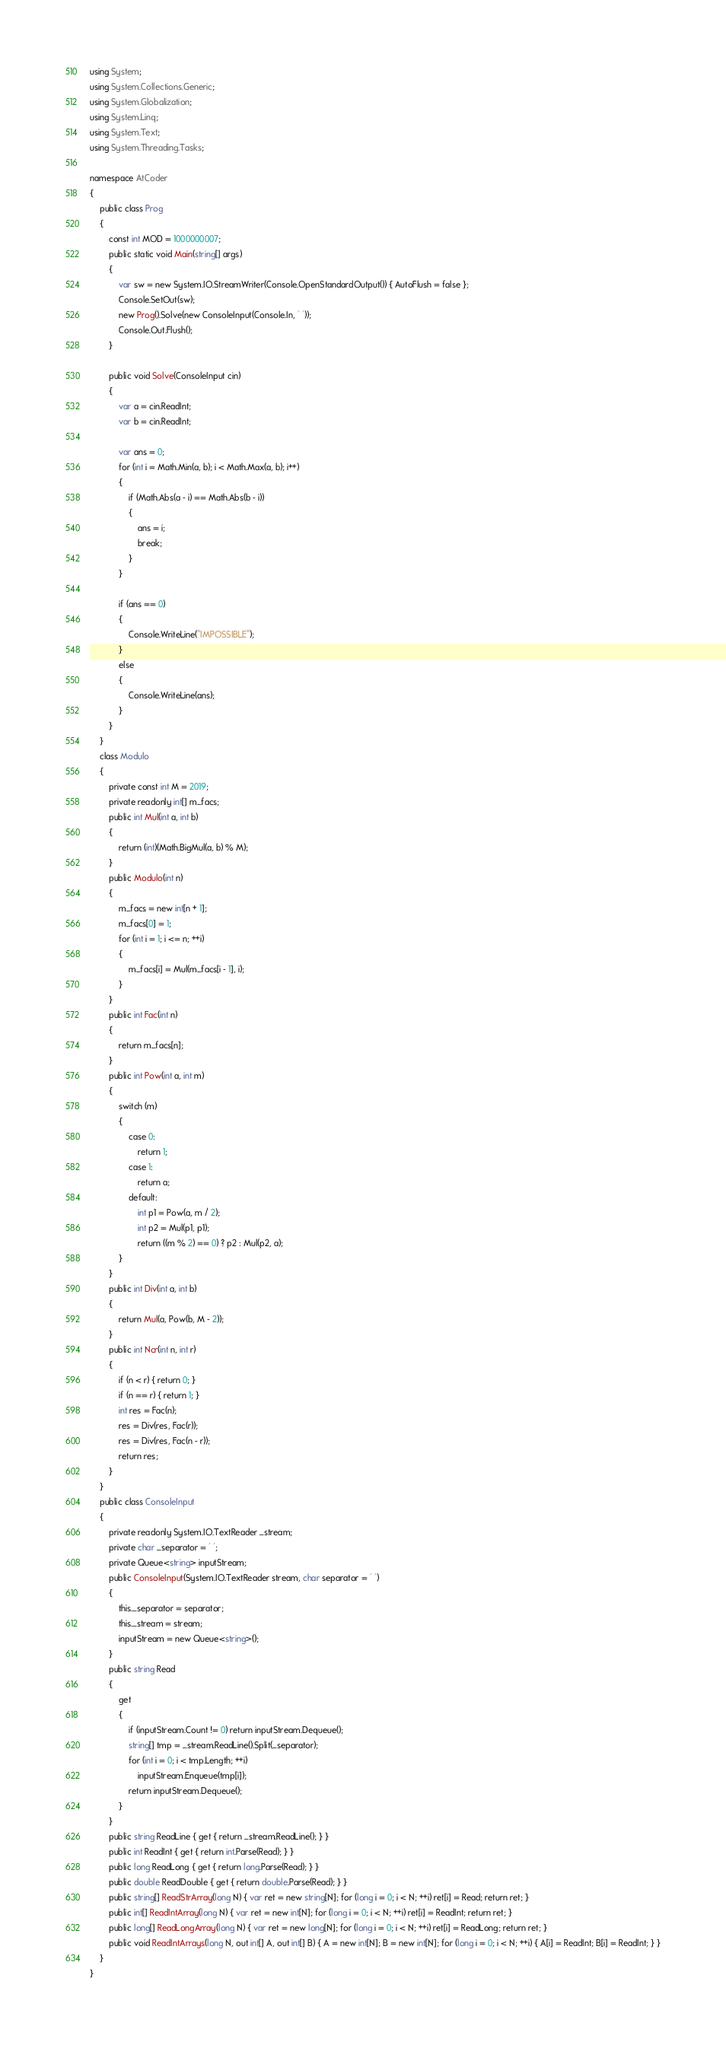<code> <loc_0><loc_0><loc_500><loc_500><_C#_>using System;
using System.Collections.Generic;
using System.Globalization;
using System.Linq;
using System.Text;
using System.Threading.Tasks;

namespace AtCoder
{
    public class Prog
    {
        const int MOD = 1000000007;
        public static void Main(string[] args)
        {
            var sw = new System.IO.StreamWriter(Console.OpenStandardOutput()) { AutoFlush = false };
            Console.SetOut(sw);
            new Prog().Solve(new ConsoleInput(Console.In, ' '));
            Console.Out.Flush();
        }

        public void Solve(ConsoleInput cin)
        {
            var a = cin.ReadInt;
            var b = cin.ReadInt;

            var ans = 0;
            for (int i = Math.Min(a, b); i < Math.Max(a, b); i++)
            {
                if (Math.Abs(a - i) == Math.Abs(b - i))
                {
                    ans = i;
                    break;
                }
            }

            if (ans == 0)
            {
                Console.WriteLine("IMPOSSIBLE");
            }
            else
            {
                Console.WriteLine(ans);
            }
        }
    }
    class Modulo
    {
        private const int M = 2019;
        private readonly int[] m_facs;
        public int Mul(int a, int b)
        {
            return (int)(Math.BigMul(a, b) % M);
        }
        public Modulo(int n)
        {
            m_facs = new int[n + 1];
            m_facs[0] = 1;
            for (int i = 1; i <= n; ++i)
            {
                m_facs[i] = Mul(m_facs[i - 1], i);
            }
        }
        public int Fac(int n)
        {
            return m_facs[n];
        }
        public int Pow(int a, int m)
        {
            switch (m)
            {
                case 0:
                    return 1;
                case 1:
                    return a;
                default:
                    int p1 = Pow(a, m / 2);
                    int p2 = Mul(p1, p1);
                    return ((m % 2) == 0) ? p2 : Mul(p2, a);
            }
        }
        public int Div(int a, int b)
        {
            return Mul(a, Pow(b, M - 2));
        }
        public int Ncr(int n, int r)
        {
            if (n < r) { return 0; }
            if (n == r) { return 1; }
            int res = Fac(n);
            res = Div(res, Fac(r));
            res = Div(res, Fac(n - r));
            return res;
        }
    }
    public class ConsoleInput
    {
        private readonly System.IO.TextReader _stream;
        private char _separator = ' ';
        private Queue<string> inputStream;
        public ConsoleInput(System.IO.TextReader stream, char separator = ' ')
        {
            this._separator = separator;
            this._stream = stream;
            inputStream = new Queue<string>();
        }
        public string Read
        {
            get
            {
                if (inputStream.Count != 0) return inputStream.Dequeue();
                string[] tmp = _stream.ReadLine().Split(_separator);
                for (int i = 0; i < tmp.Length; ++i)
                    inputStream.Enqueue(tmp[i]);
                return inputStream.Dequeue();
            }
        }
        public string ReadLine { get { return _stream.ReadLine(); } }
        public int ReadInt { get { return int.Parse(Read); } }
        public long ReadLong { get { return long.Parse(Read); } }
        public double ReadDouble { get { return double.Parse(Read); } }
        public string[] ReadStrArray(long N) { var ret = new string[N]; for (long i = 0; i < N; ++i) ret[i] = Read; return ret; }
        public int[] ReadIntArray(long N) { var ret = new int[N]; for (long i = 0; i < N; ++i) ret[i] = ReadInt; return ret; }
        public long[] ReadLongArray(long N) { var ret = new long[N]; for (long i = 0; i < N; ++i) ret[i] = ReadLong; return ret; }
        public void ReadIntArrays(long N, out int[] A, out int[] B) { A = new int[N]; B = new int[N]; for (long i = 0; i < N; ++i) { A[i] = ReadInt; B[i] = ReadInt; } }
    }
}
</code> 